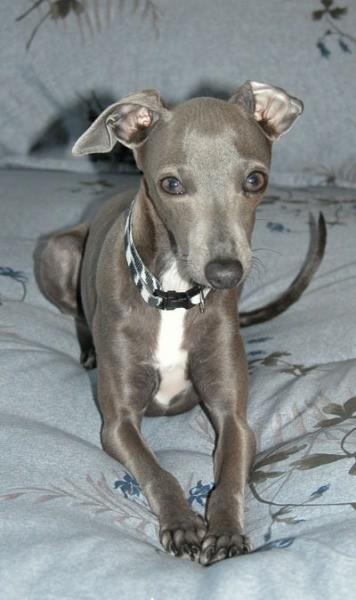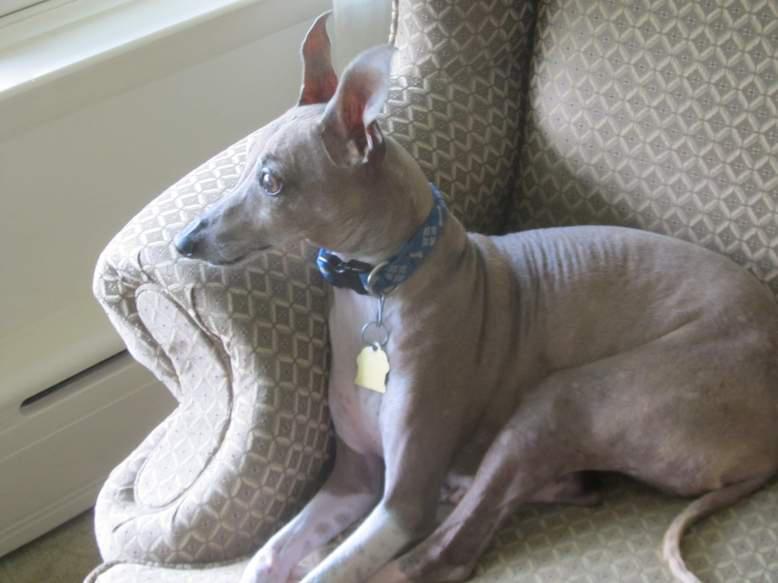The first image is the image on the left, the second image is the image on the right. Given the left and right images, does the statement "There are no more than two Italian greyhounds, all wearing collars." hold true? Answer yes or no. Yes. The first image is the image on the left, the second image is the image on the right. Analyze the images presented: Is the assertion "There are four dogs." valid? Answer yes or no. No. 